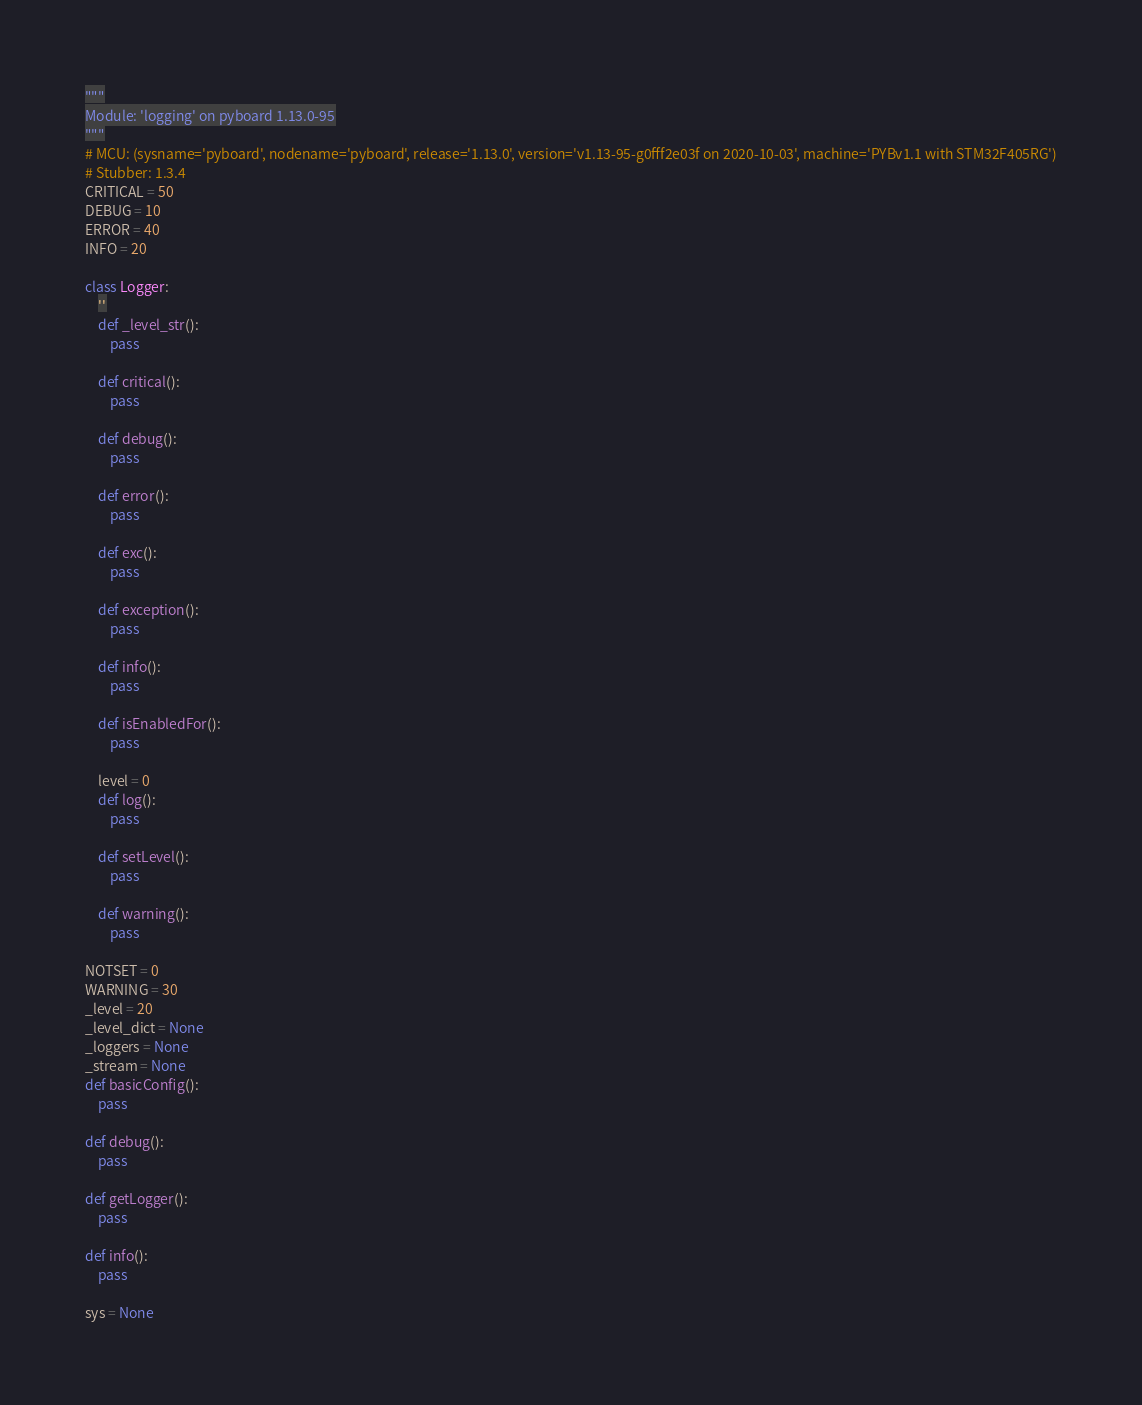<code> <loc_0><loc_0><loc_500><loc_500><_Python_>"""
Module: 'logging' on pyboard 1.13.0-95
"""
# MCU: (sysname='pyboard', nodename='pyboard', release='1.13.0', version='v1.13-95-g0fff2e03f on 2020-10-03', machine='PYBv1.1 with STM32F405RG')
# Stubber: 1.3.4
CRITICAL = 50
DEBUG = 10
ERROR = 40
INFO = 20

class Logger:
    ''
    def _level_str():
        pass

    def critical():
        pass

    def debug():
        pass

    def error():
        pass

    def exc():
        pass

    def exception():
        pass

    def info():
        pass

    def isEnabledFor():
        pass

    level = 0
    def log():
        pass

    def setLevel():
        pass

    def warning():
        pass

NOTSET = 0
WARNING = 30
_level = 20
_level_dict = None
_loggers = None
_stream = None
def basicConfig():
    pass

def debug():
    pass

def getLogger():
    pass

def info():
    pass

sys = None
</code> 